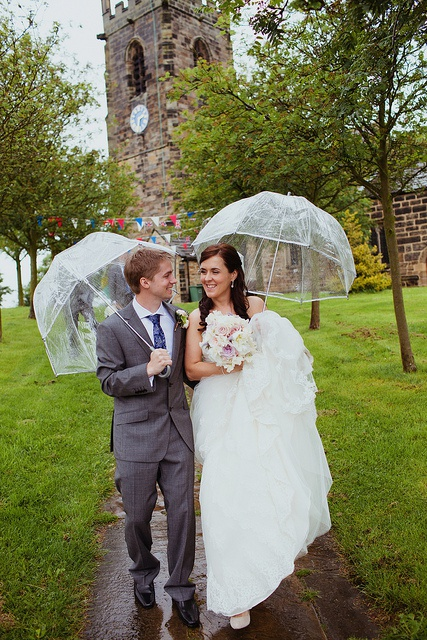Describe the objects in this image and their specific colors. I can see people in lavender, lightgray, darkgray, black, and tan tones, people in lavender, gray, and black tones, umbrella in lavender, lightgray, darkgray, gray, and olive tones, clock in lavender, lightgray, lightblue, and darkgray tones, and tie in lavender, blue, navy, black, and purple tones in this image. 